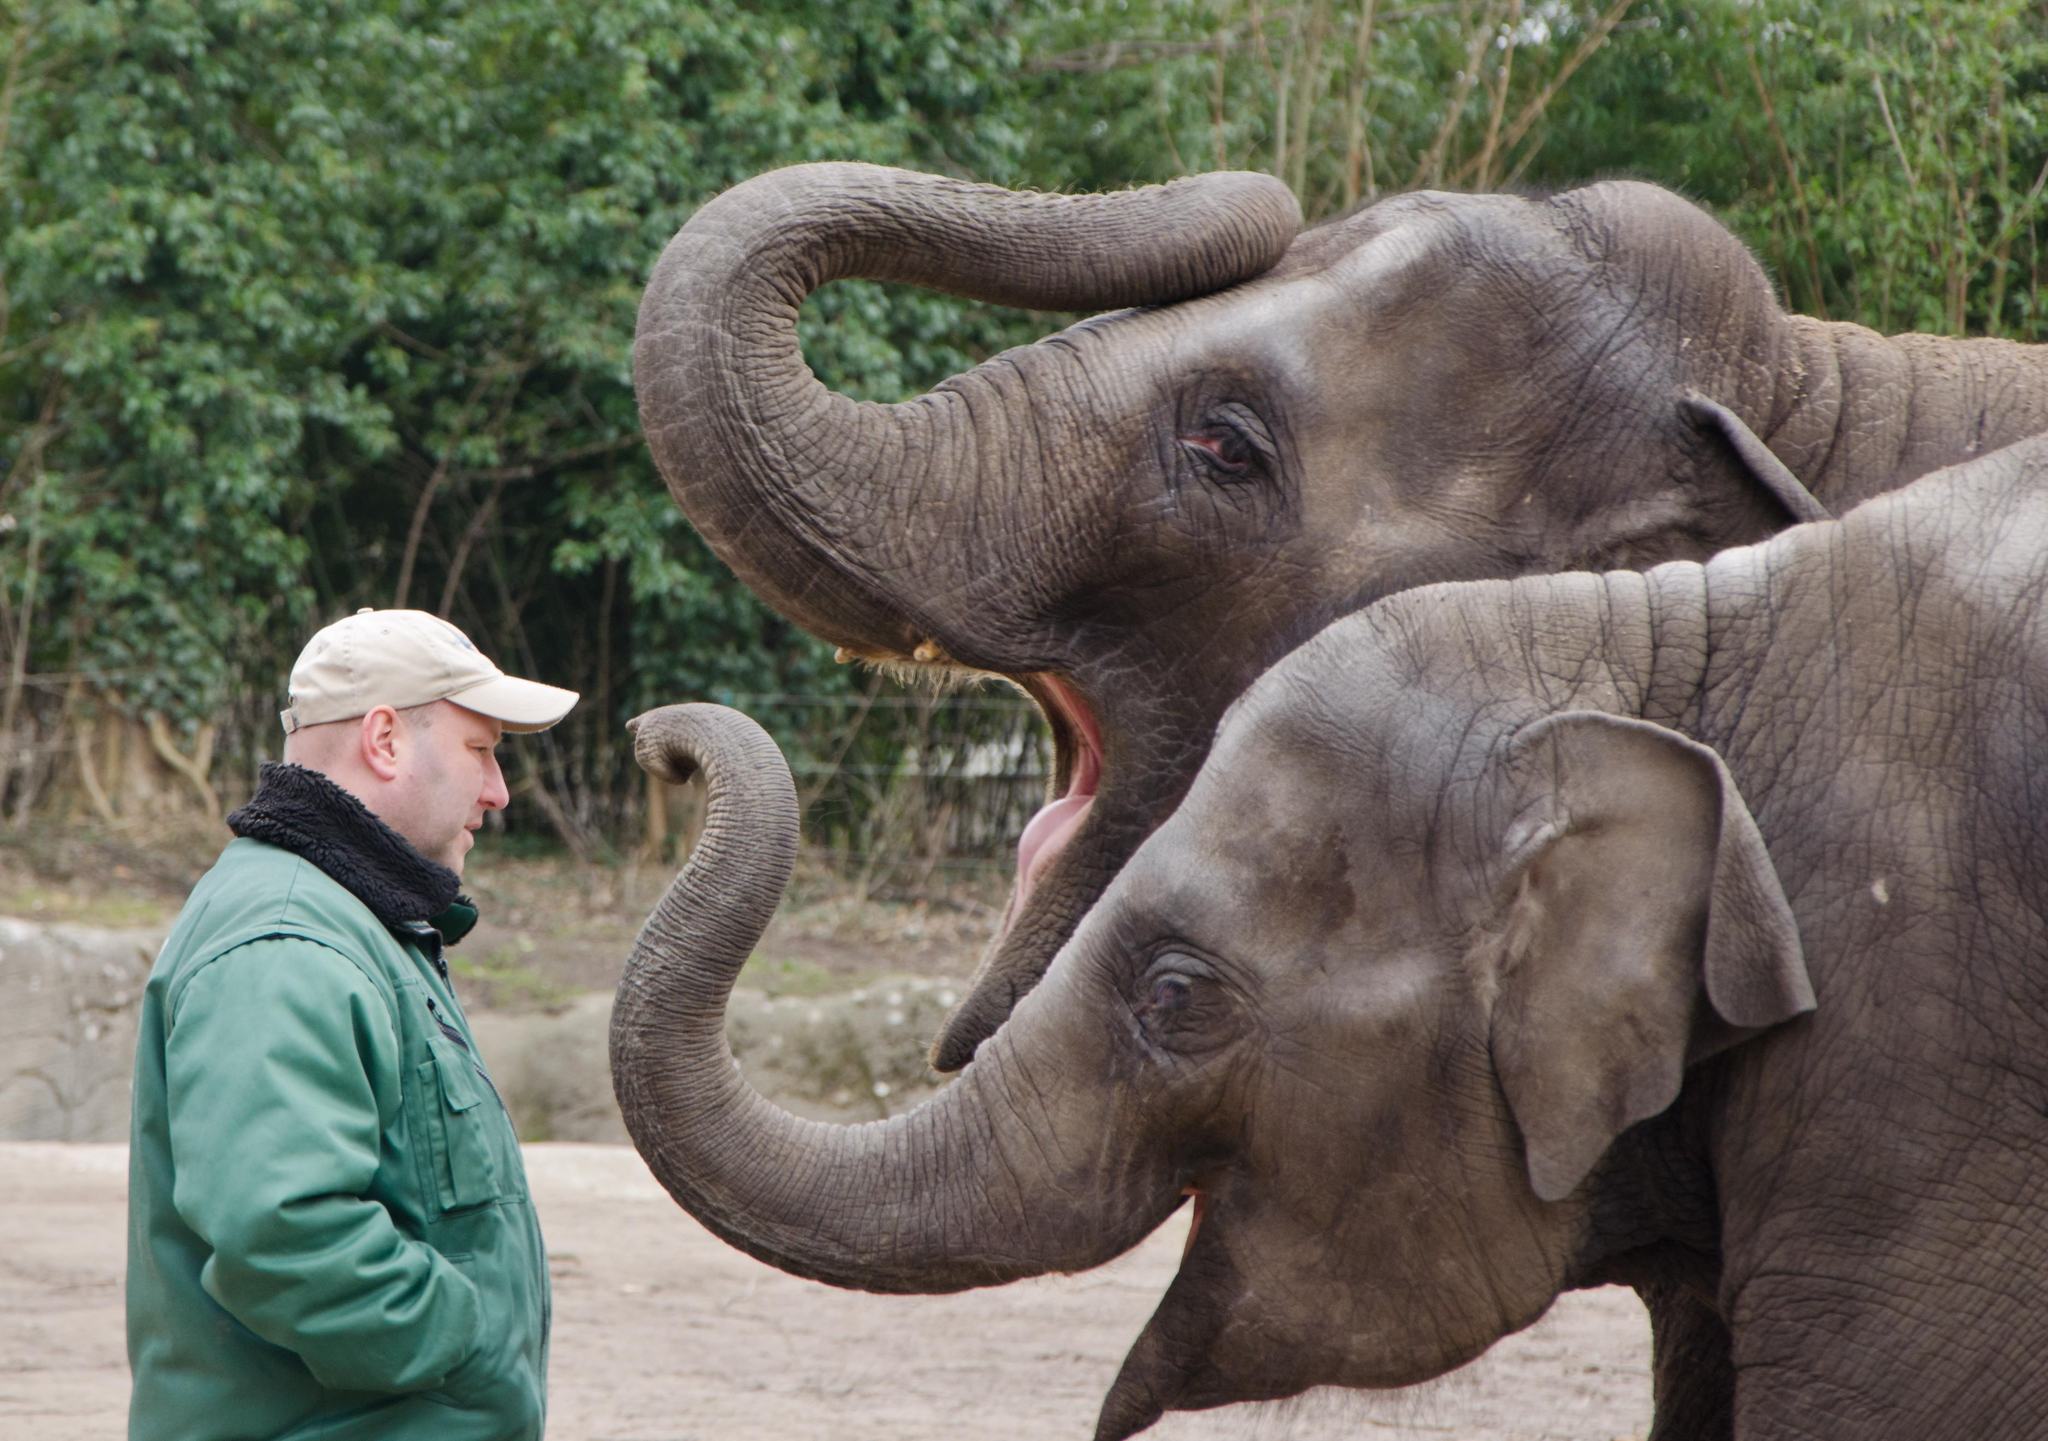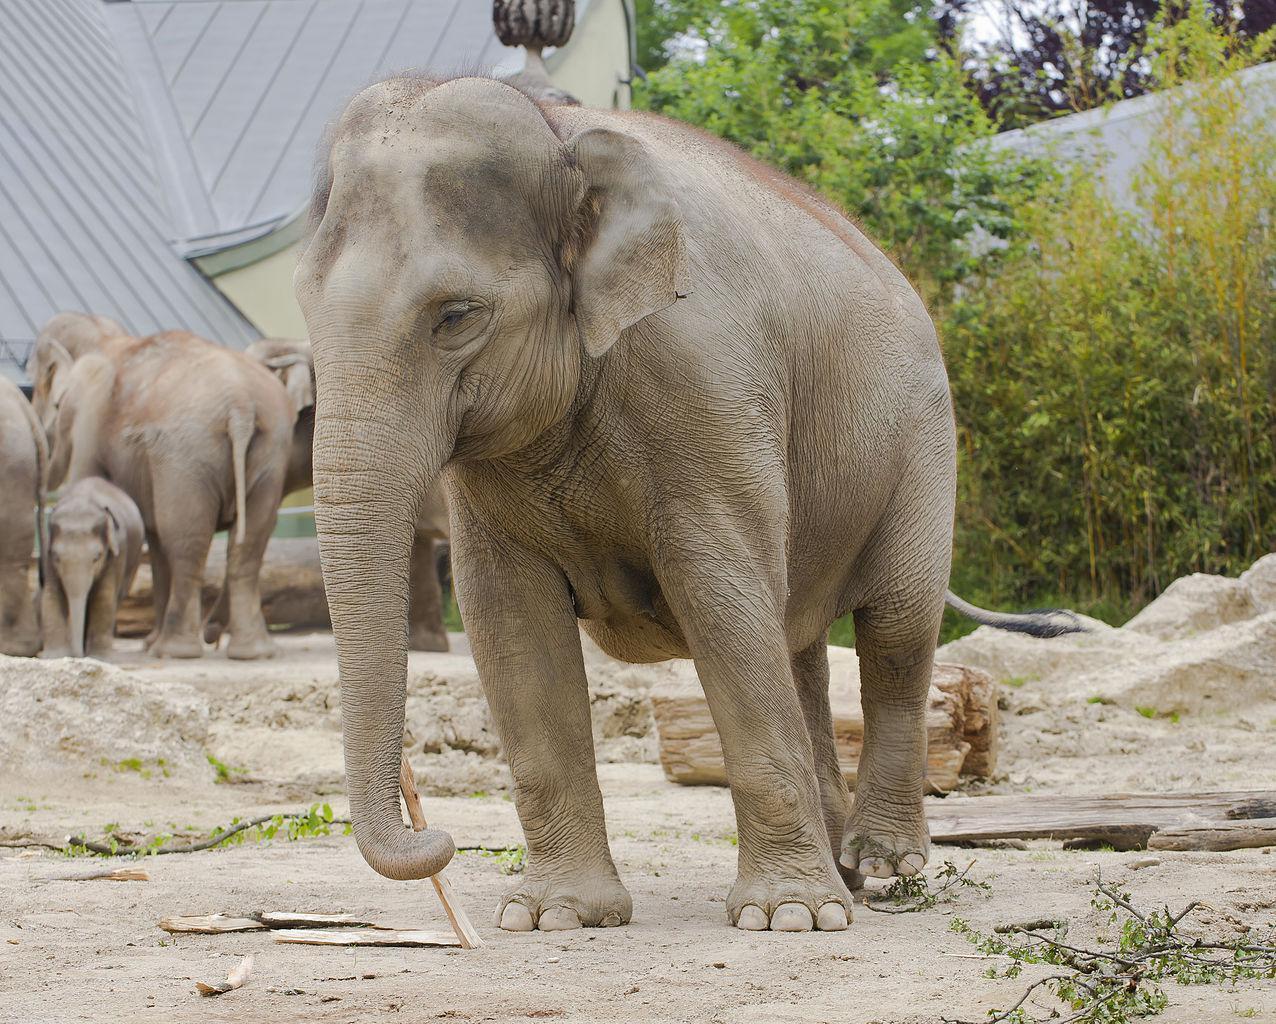The first image is the image on the left, the second image is the image on the right. For the images displayed, is the sentence "There is at least one elephant lifting its trunk in the air." factually correct? Answer yes or no. Yes. The first image is the image on the left, the second image is the image on the right. For the images displayed, is the sentence "At least one elephant has it's trunk raised in one image." factually correct? Answer yes or no. Yes. 